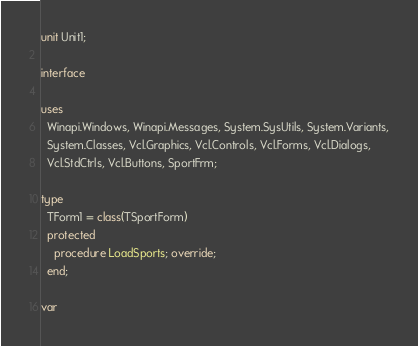Convert code to text. <code><loc_0><loc_0><loc_500><loc_500><_Pascal_>unit Unit1;

interface

uses
  Winapi.Windows, Winapi.Messages, System.SysUtils, System.Variants,
  System.Classes, Vcl.Graphics, Vcl.Controls, Vcl.Forms, Vcl.Dialogs,
  Vcl.StdCtrls, Vcl.Buttons, SportFrm;

type
  TForm1 = class(TSportForm)
  protected
    procedure LoadSports; override;
  end;

var</code> 